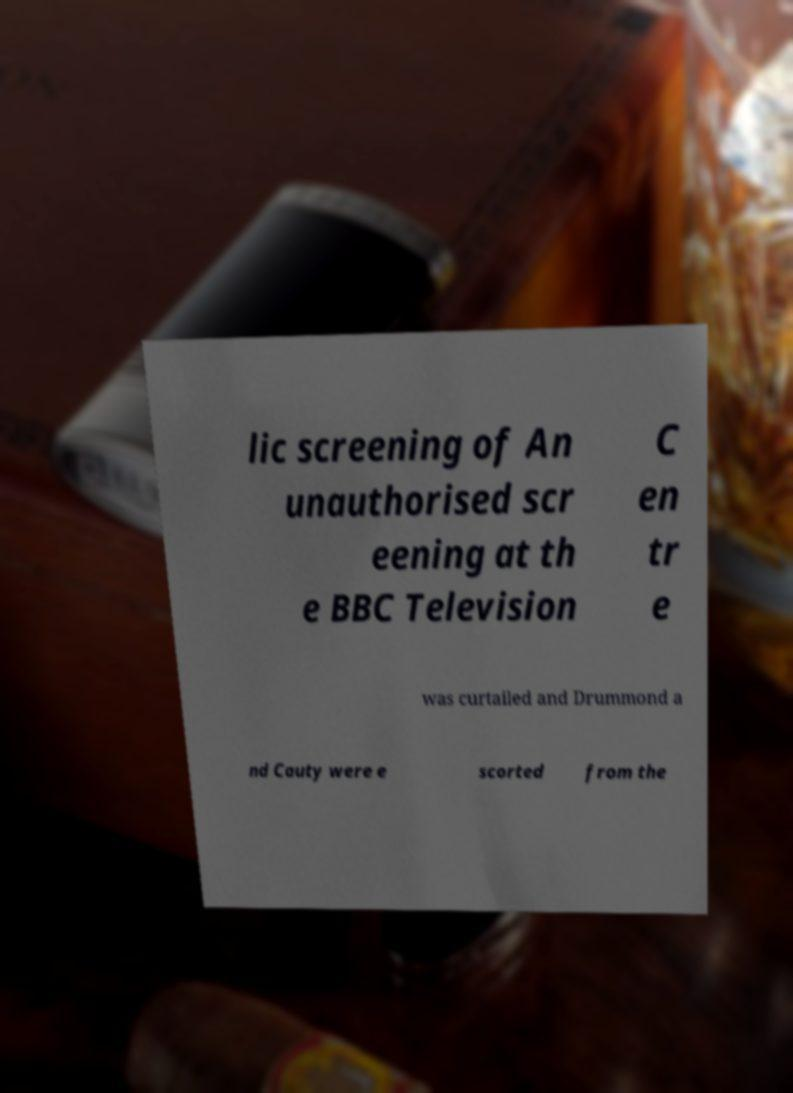There's text embedded in this image that I need extracted. Can you transcribe it verbatim? lic screening of An unauthorised scr eening at th e BBC Television C en tr e was curtailed and Drummond a nd Cauty were e scorted from the 